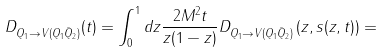<formula> <loc_0><loc_0><loc_500><loc_500>D _ { Q _ { 1 } \to V ( Q _ { 1 } \bar { Q } _ { 2 } ) } ( t ) = \int _ { 0 } ^ { 1 } d z \frac { 2 M ^ { 2 } t } { z ( 1 - z ) } D _ { Q _ { 1 } \to V ( Q _ { 1 } \bar { Q } _ { 2 } ) } \left ( z , s ( z , t ) \right ) =</formula> 